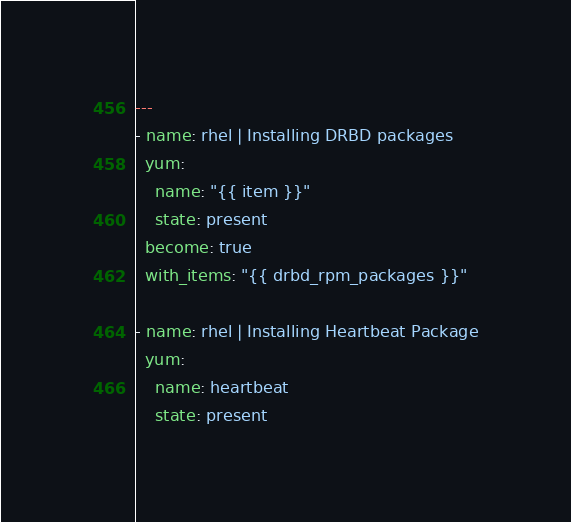Convert code to text. <code><loc_0><loc_0><loc_500><loc_500><_YAML_>---
- name: rhel | Installing DRBD packages
  yum:
    name: "{{ item }}"
    state: present
  become: true
  with_items: "{{ drbd_rpm_packages }}"

- name: rhel | Installing Heartbeat Package
  yum:
    name: heartbeat
    state: present</code> 